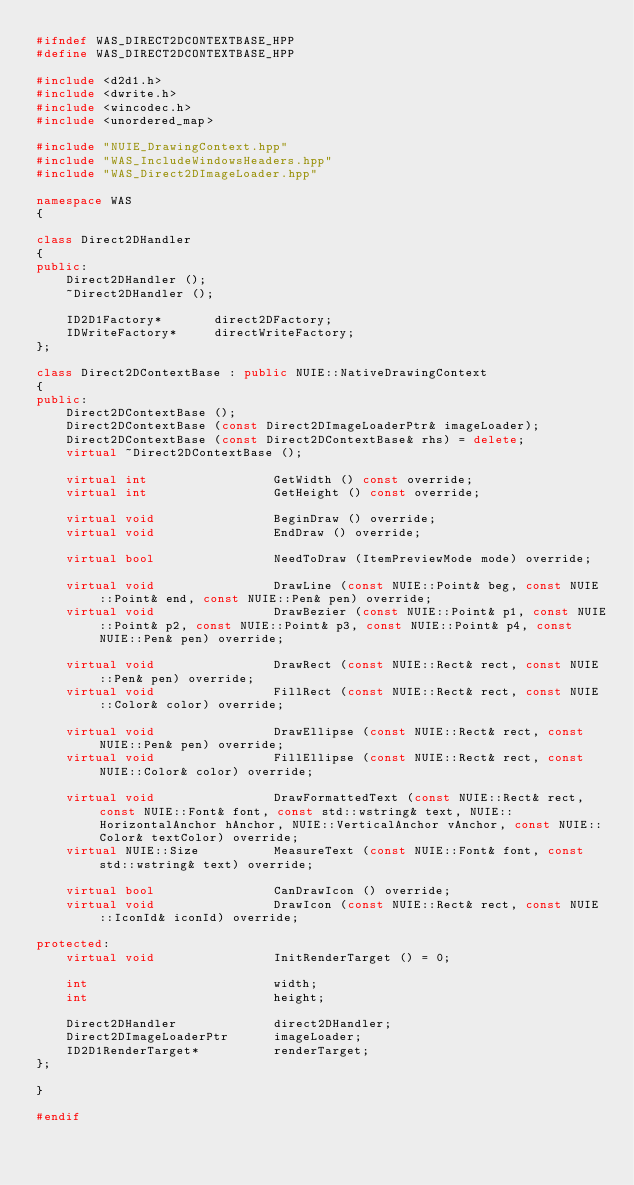Convert code to text. <code><loc_0><loc_0><loc_500><loc_500><_C++_>#ifndef WAS_DIRECT2DCONTEXTBASE_HPP
#define WAS_DIRECT2DCONTEXTBASE_HPP

#include <d2d1.h>
#include <dwrite.h>
#include <wincodec.h>
#include <unordered_map>

#include "NUIE_DrawingContext.hpp"
#include "WAS_IncludeWindowsHeaders.hpp"
#include "WAS_Direct2DImageLoader.hpp"

namespace WAS
{

class Direct2DHandler
{
public:
	Direct2DHandler ();
	~Direct2DHandler ();

	ID2D1Factory*		direct2DFactory;
	IDWriteFactory*		directWriteFactory;
};

class Direct2DContextBase : public NUIE::NativeDrawingContext
{
public:
	Direct2DContextBase ();
	Direct2DContextBase (const Direct2DImageLoaderPtr& imageLoader);
	Direct2DContextBase (const Direct2DContextBase& rhs) = delete;
	virtual ~Direct2DContextBase ();

	virtual int					GetWidth () const override;
	virtual int					GetHeight () const override;

	virtual void				BeginDraw () override;
	virtual void				EndDraw () override;

	virtual bool				NeedToDraw (ItemPreviewMode mode) override;

	virtual void				DrawLine (const NUIE::Point& beg, const NUIE::Point& end, const NUIE::Pen& pen) override;
	virtual void				DrawBezier (const NUIE::Point& p1, const NUIE::Point& p2, const NUIE::Point& p3, const NUIE::Point& p4, const NUIE::Pen& pen) override;

	virtual void				DrawRect (const NUIE::Rect& rect, const NUIE::Pen& pen) override;
	virtual void				FillRect (const NUIE::Rect& rect, const NUIE::Color& color) override;

	virtual void				DrawEllipse (const NUIE::Rect& rect, const NUIE::Pen& pen) override;
	virtual void				FillEllipse (const NUIE::Rect& rect, const NUIE::Color& color) override;

	virtual void				DrawFormattedText (const NUIE::Rect& rect, const NUIE::Font& font, const std::wstring& text, NUIE::HorizontalAnchor hAnchor, NUIE::VerticalAnchor vAnchor, const NUIE::Color& textColor) override;
	virtual NUIE::Size			MeasureText (const NUIE::Font& font, const std::wstring& text) override;

	virtual bool				CanDrawIcon () override;
	virtual void				DrawIcon (const NUIE::Rect& rect, const NUIE::IconId& iconId) override;

protected:
	virtual void				InitRenderTarget () = 0;

	int							width;
	int							height;

	Direct2DHandler				direct2DHandler;
	Direct2DImageLoaderPtr		imageLoader;
	ID2D1RenderTarget*			renderTarget;
};

}

#endif
</code> 